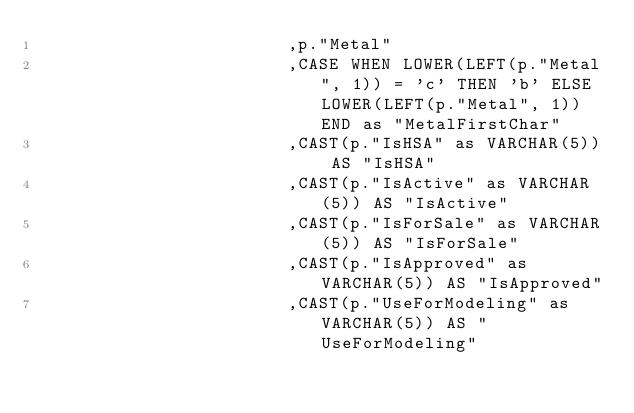<code> <loc_0><loc_0><loc_500><loc_500><_SQL_>                        ,p."Metal"
                        ,CASE WHEN LOWER(LEFT(p."Metal", 1)) = 'c' THEN 'b' ELSE LOWER(LEFT(p."Metal", 1)) END as "MetalFirstChar"
                        ,CAST(p."IsHSA" as VARCHAR(5)) AS "IsHSA"
                        ,CAST(p."IsActive" as VARCHAR(5)) AS "IsActive"
                        ,CAST(p."IsForSale" as VARCHAR(5)) AS "IsForSale"
                        ,CAST(p."IsApproved" as VARCHAR(5)) AS "IsApproved"
                        ,CAST(p."UseForModeling" as VARCHAR(5)) AS "UseForModeling"</code> 